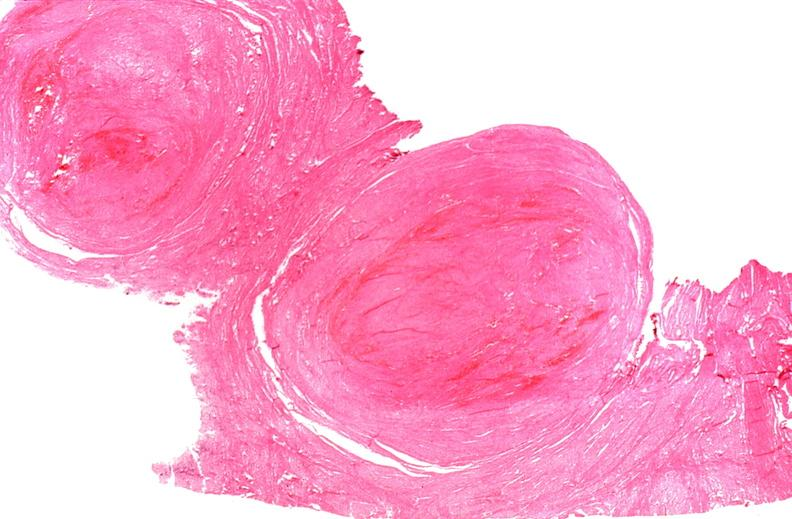where is this from?
Answer the question using a single word or phrase. Female reproductive system 